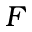<formula> <loc_0><loc_0><loc_500><loc_500>F</formula> 